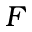<formula> <loc_0><loc_0><loc_500><loc_500>F</formula> 